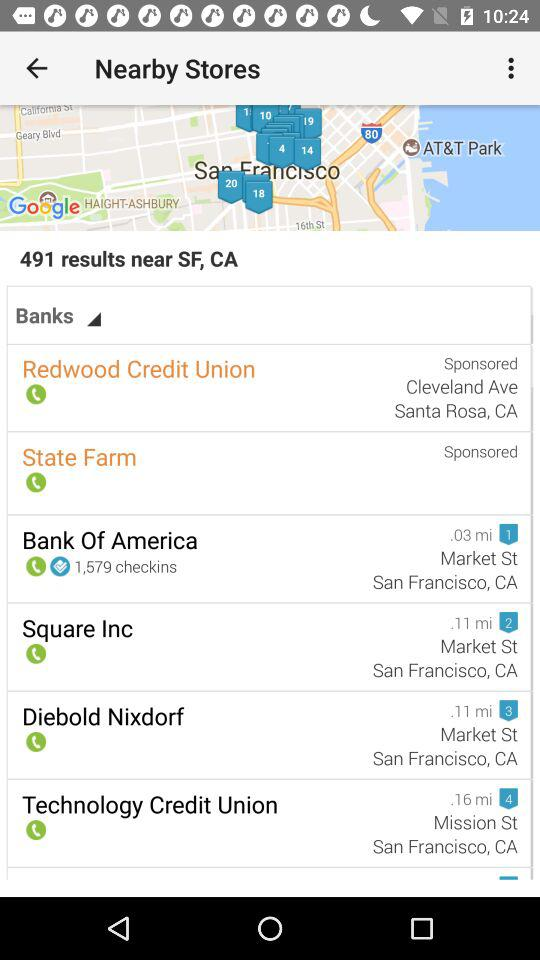What's the nearest bank to the search area's center on the map? The map indicates that the Bank of America is the nearest listed bank to the center of the search area, it's only 0.03 miles away, making it highly accessible. 